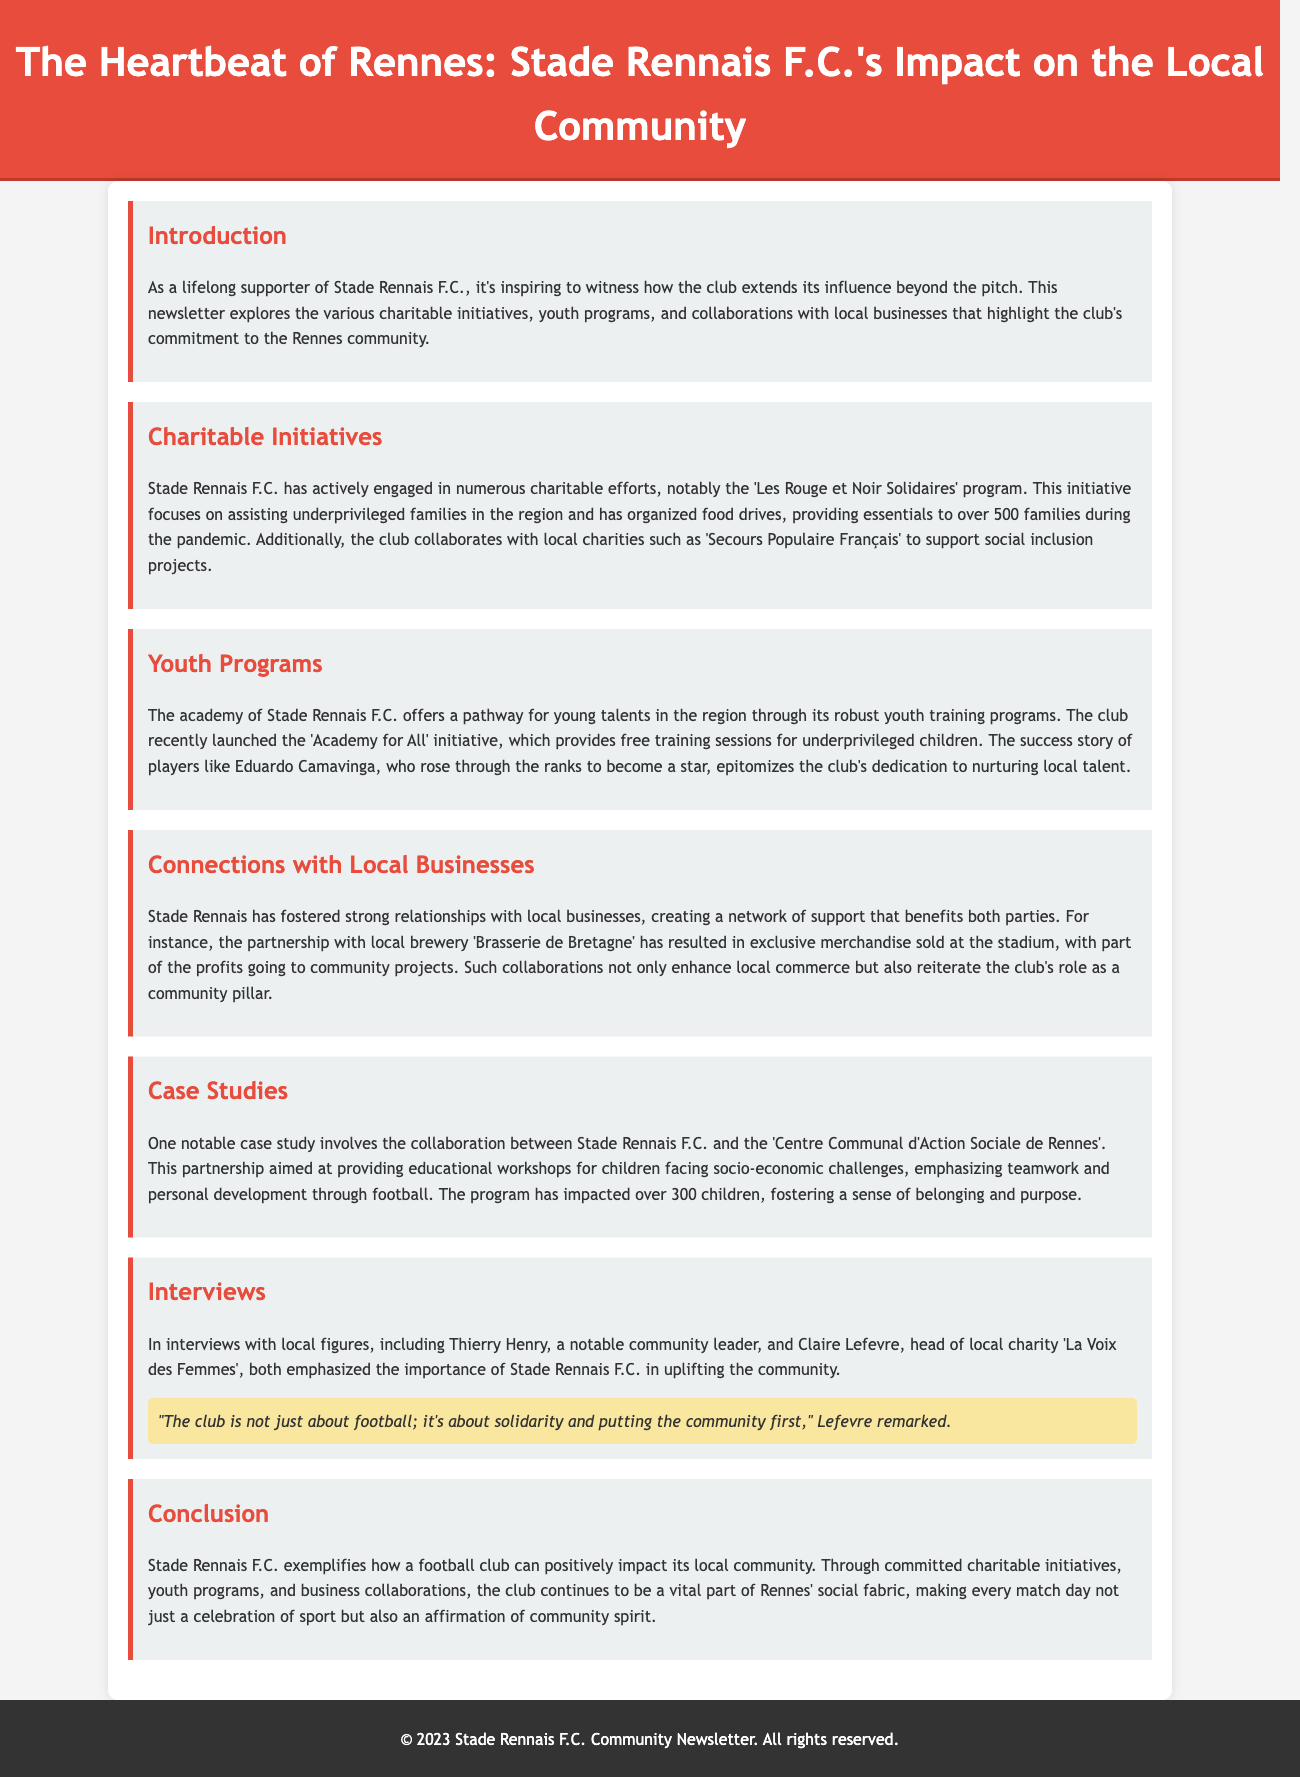What is the name of the program focusing on underprivileged families? The program 'Les Rouge et Noir Solidaires' assists underprivileged families in the region.
Answer: Les Rouge et Noir Solidaires How many families received assistance during the pandemic? The document states that the program provided essentials to over 500 families during the pandemic.
Answer: over 500 What initiative provides free training sessions for underprivileged children? The initiative mentioned for providing free training sessions is called 'Academy for All'.
Answer: Academy for All Which local brewery partnered with Stade Rennais F.C.? The partnership mentioned is with 'Brasserie de Bretagne'.
Answer: Brasserie de Bretagne How many children were impacted by the workshops offered through the partnership with the 'Centre Communal d'Action Sociale de Rennes'? The program has impacted over 300 children through educational workshops.
Answer: over 300 Who highlighted the club's role as a community pillar in interviews? Both Thierry Henry and Claire Lefevre emphasized the club's importance in the community.
Answer: Thierry Henry and Claire Lefevre What is the primary focus of the 'Centre Communal d'Action Sociale de Rennes' partnership? The partnership focuses on providing educational workshops for children facing socio-economic challenges.
Answer: educational workshops What color theme is prominent in the header of the newsletter? The header features a red color theme.
Answer: red What is the title of this newsletter? The title of the newsletter is 'The Heartbeat of Rennes: Stade Rennais F.C.'s Impact on the Local Community'.
Answer: The Heartbeat of Rennes: Stade Rennais F.C.'s Impact on the Local Community 